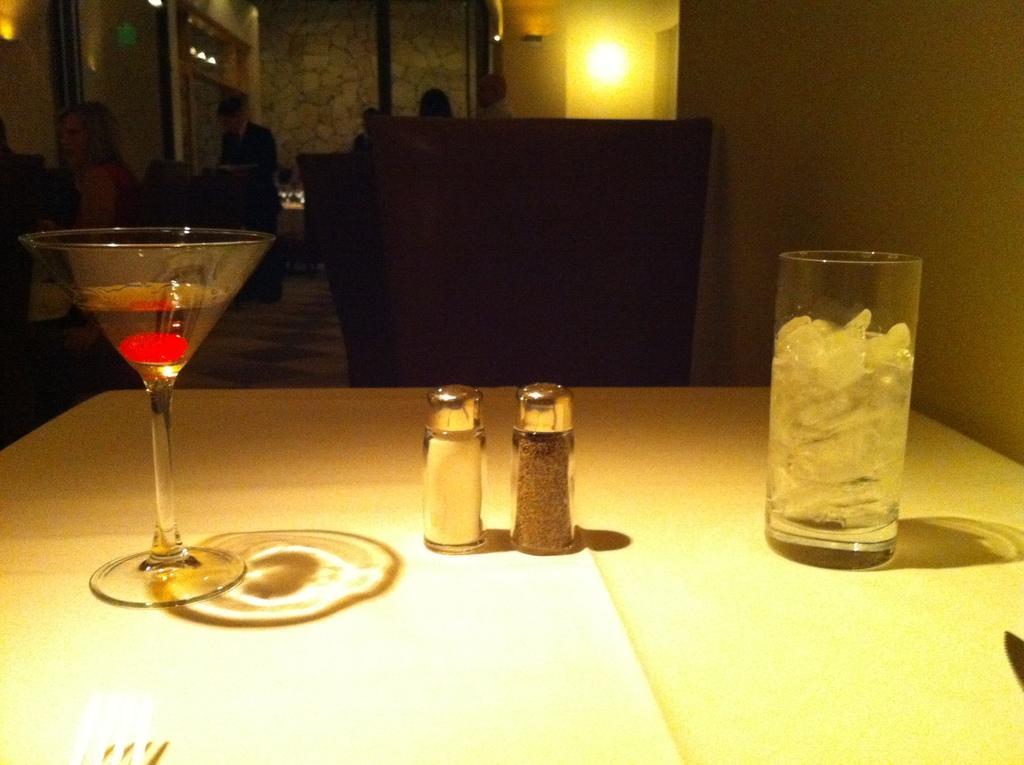Describe this image in one or two sentences. In this picture there is a wine glass with a drink in it and pepper and salt bottles and glass filled with ice cubes placed on the table. In the background i could see some persons sitting on the chairs and some light on the wall. 